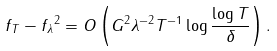Convert formula to latex. <formula><loc_0><loc_0><loc_500><loc_500>\| f _ { T } - f _ { \lambda } \| ^ { 2 } = O \left ( G ^ { 2 } \lambda ^ { - 2 } T ^ { - 1 } \log \frac { \log T } { \delta } \right ) .</formula> 